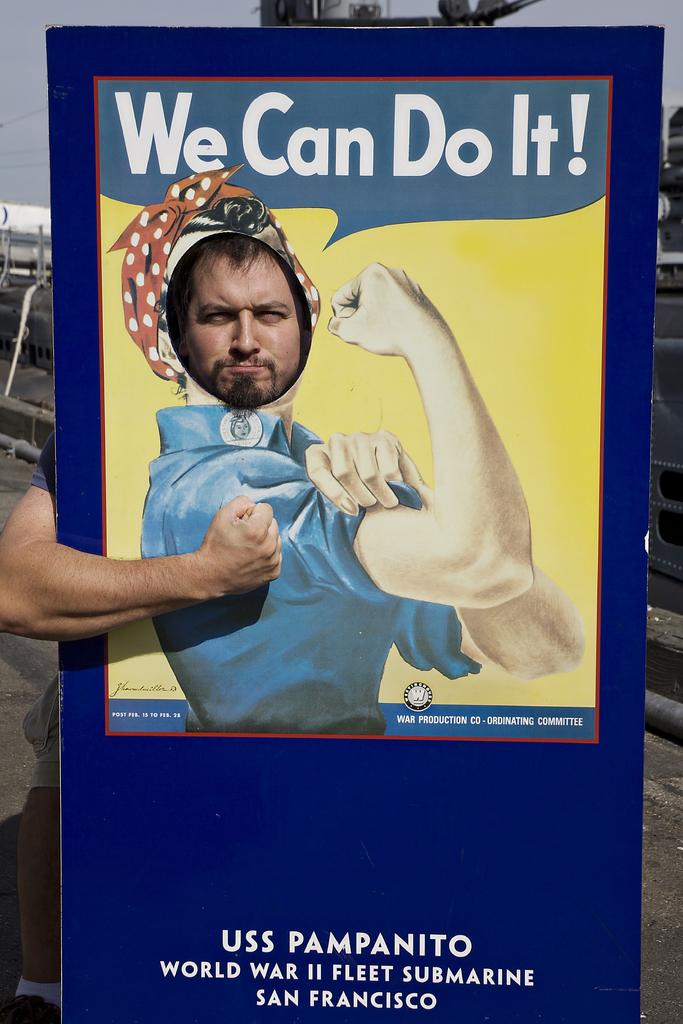Who is present in the image? There is a man in the image. What is the man holding in the image? The man is holding an advertisement board. What can be seen in the background of the image? There is sky visible in the background of the image. Where is the nest located in the image? There is no nest present in the image. What type of force is being applied by the man in the image? The man is not applying any force in the image; he is simply holding an advertisement board. 